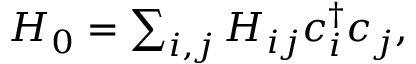<formula> <loc_0><loc_0><loc_500><loc_500>\begin{array} { r } { H _ { 0 } = \sum _ { i , j } H _ { i j } c _ { i } ^ { \dagger } c _ { j } , } \end{array}</formula> 